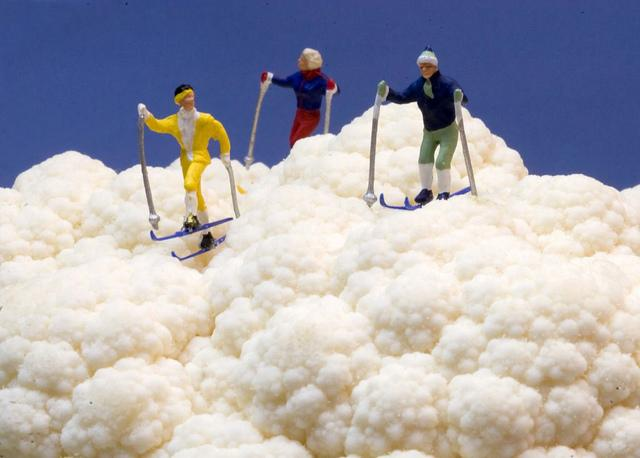What material was used to depict the snow in this art piece?

Choices:
A) bubbles
B) cotton
C) feathers
D) yarn cotton 